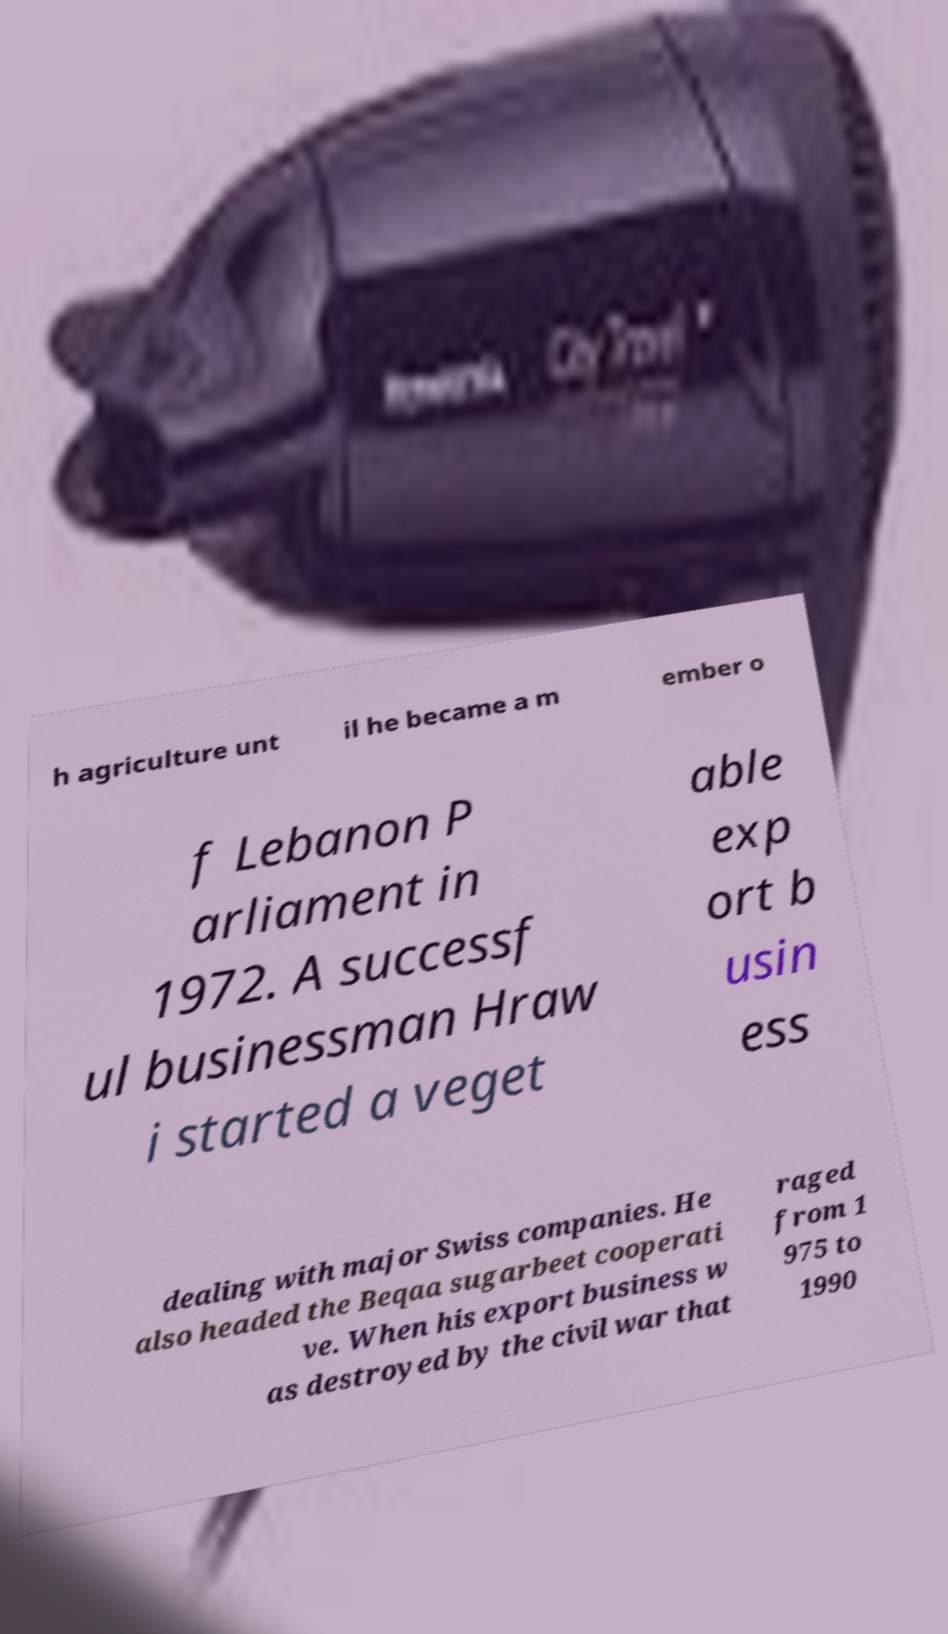There's text embedded in this image that I need extracted. Can you transcribe it verbatim? h agriculture unt il he became a m ember o f Lebanon P arliament in 1972. A successf ul businessman Hraw i started a veget able exp ort b usin ess dealing with major Swiss companies. He also headed the Beqaa sugarbeet cooperati ve. When his export business w as destroyed by the civil war that raged from 1 975 to 1990 